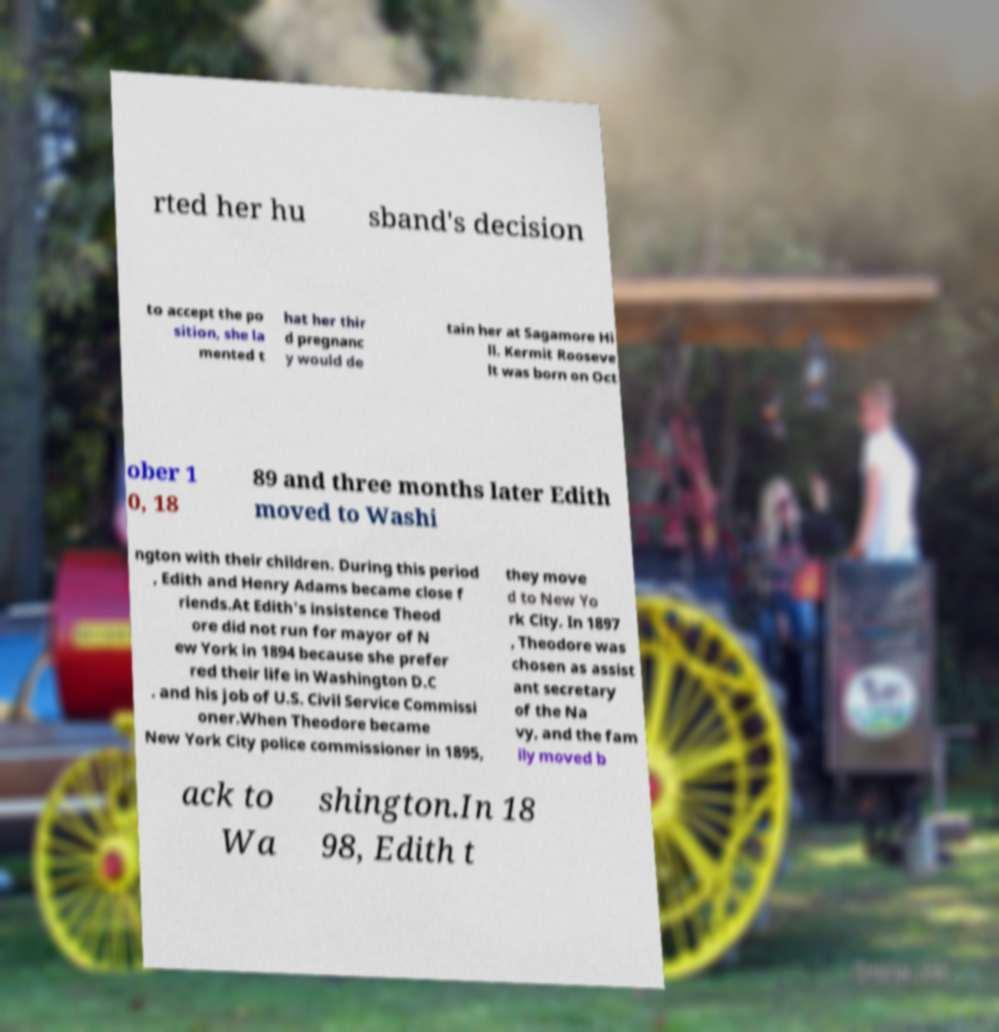Could you extract and type out the text from this image? rted her hu sband's decision to accept the po sition, she la mented t hat her thir d pregnanc y would de tain her at Sagamore Hi ll. Kermit Rooseve lt was born on Oct ober 1 0, 18 89 and three months later Edith moved to Washi ngton with their children. During this period , Edith and Henry Adams became close f riends.At Edith's insistence Theod ore did not run for mayor of N ew York in 1894 because she prefer red their life in Washington D.C . and his job of U.S. Civil Service Commissi oner.When Theodore became New York City police commissioner in 1895, they move d to New Yo rk City. In 1897 , Theodore was chosen as assist ant secretary of the Na vy, and the fam ily moved b ack to Wa shington.In 18 98, Edith t 